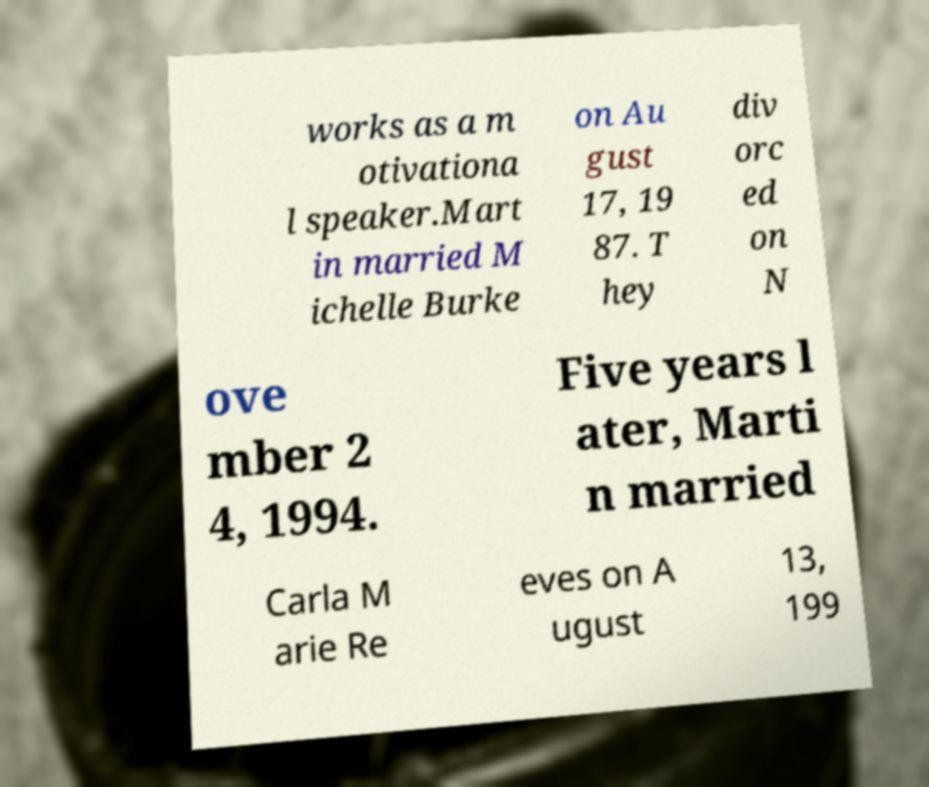I need the written content from this picture converted into text. Can you do that? works as a m otivationa l speaker.Mart in married M ichelle Burke on Au gust 17, 19 87. T hey div orc ed on N ove mber 2 4, 1994. Five years l ater, Marti n married Carla M arie Re eves on A ugust 13, 199 